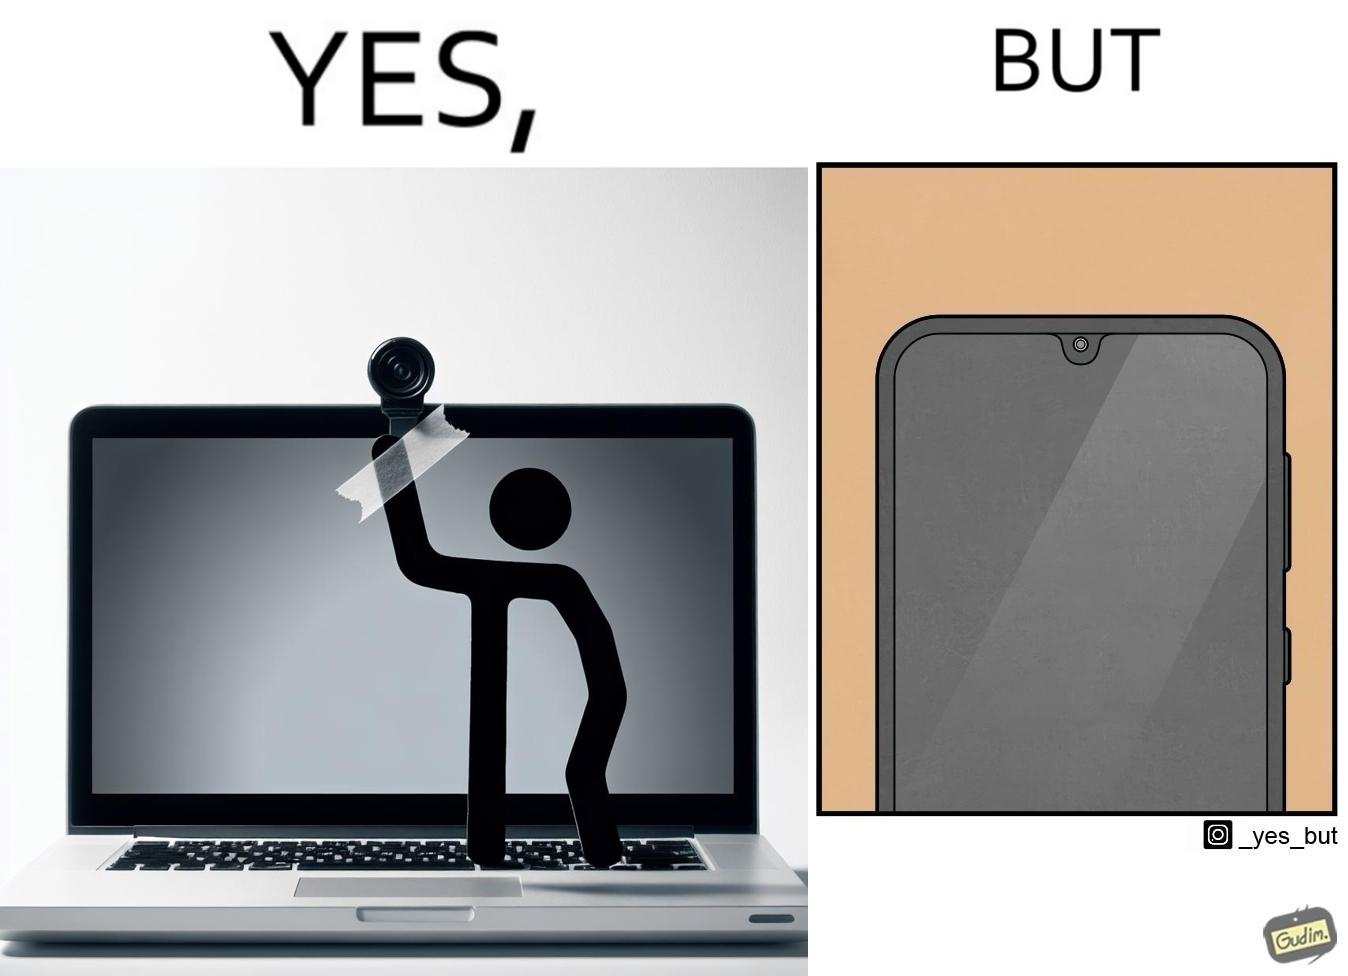Is this a satirical image? Yes, this image is satirical. 